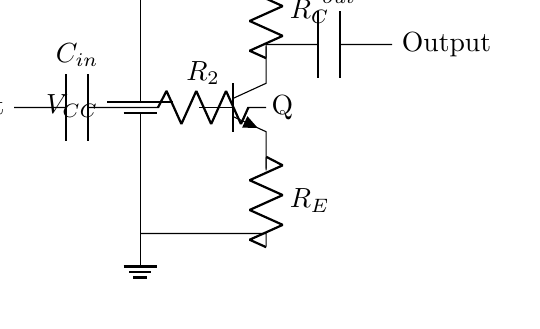What type of transistor is used in this circuit? The circuit diagram indicates an npn transistor, as denoted by the notation "Q" and the direction of the arrow on the transistor symbol. In an npn transistor, the arrow points outward, indicating that current flows out of the base.
Answer: npn What are the components connected to the transistor? The transistor is connected to three resistors (R1, RC, and RE) and one coupling capacitor for input (Cin) and one for output (Cout). Each of these components plays a role in biasing and signal amplification.
Answer: Three resistors and two capacitors What is the purpose of the capacitor labeled Cin? The capacitor labeled Cin is used for coupling the input signal to the base of the transistor while blocking any DC component. This allows for the amplification of the AC signal without affecting the DC biasing of the transistor.
Answer: Coupling input signal What is the function of resistor R1 in this circuit? Resistor R1 is a biasing resistor connected to the base of the transistor. It helps to set the appropriate operating point (bias) for the transistor to ensure it operates in the desired region of its characteristic curve for amplification.
Answer: Biasing resistor What happens if R2 is too high? If R2 is too high, it can lead to insufficient base current flowing into the transistor, which may prevent it from turning on fully or producing the desired gain. This could result in weaker amplification or distortion of the output signal.
Answer: Insufficient base current How is the output taken in this circuit? The output is taken across the coupling capacitor Cout, connected to the collector of the transistor. This configuration allows the amplified AC signal to pass through while blocking any DC component that may exist.
Answer: Through Cout What does R_E do in this circuit? R_E is the emitter resistor, which helps stabilize the operating point of the transistor against variations in temperature or supply voltage. It also plays a role in feedback that can improve linearity and gain stability under different conditions.
Answer: Stabilizes operating point 